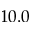Convert formula to latex. <formula><loc_0><loc_0><loc_500><loc_500>1 0 . 0</formula> 